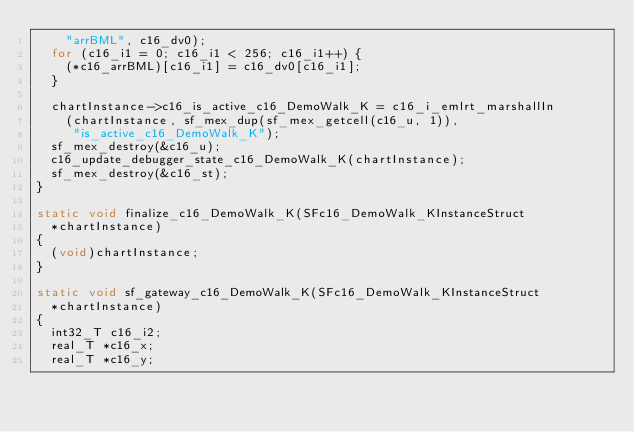<code> <loc_0><loc_0><loc_500><loc_500><_C_>    "arrBML", c16_dv0);
  for (c16_i1 = 0; c16_i1 < 256; c16_i1++) {
    (*c16_arrBML)[c16_i1] = c16_dv0[c16_i1];
  }

  chartInstance->c16_is_active_c16_DemoWalk_K = c16_i_emlrt_marshallIn
    (chartInstance, sf_mex_dup(sf_mex_getcell(c16_u, 1)),
     "is_active_c16_DemoWalk_K");
  sf_mex_destroy(&c16_u);
  c16_update_debugger_state_c16_DemoWalk_K(chartInstance);
  sf_mex_destroy(&c16_st);
}

static void finalize_c16_DemoWalk_K(SFc16_DemoWalk_KInstanceStruct
  *chartInstance)
{
  (void)chartInstance;
}

static void sf_gateway_c16_DemoWalk_K(SFc16_DemoWalk_KInstanceStruct
  *chartInstance)
{
  int32_T c16_i2;
  real_T *c16_x;
  real_T *c16_y;</code> 